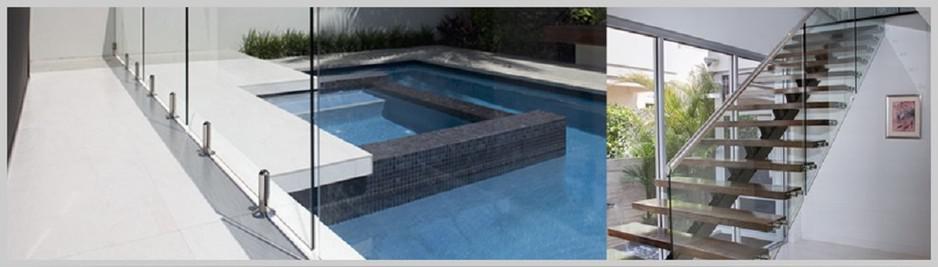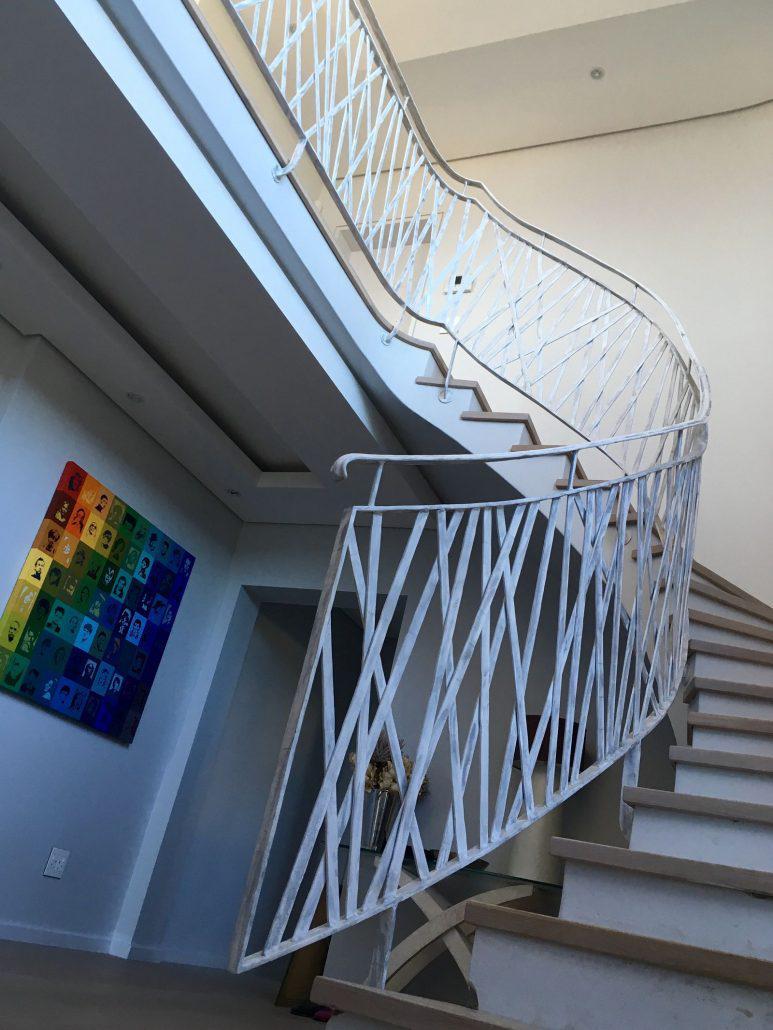The first image is the image on the left, the second image is the image on the right. Analyze the images presented: Is the assertion "Both images show an indoor staircase that has glass siding instead of banisters." valid? Answer yes or no. No. The first image is the image on the left, the second image is the image on the right. Analyze the images presented: Is the assertion "An image shows a stairwell enclosed by glass panels without a top rail or hinges." valid? Answer yes or no. No. 